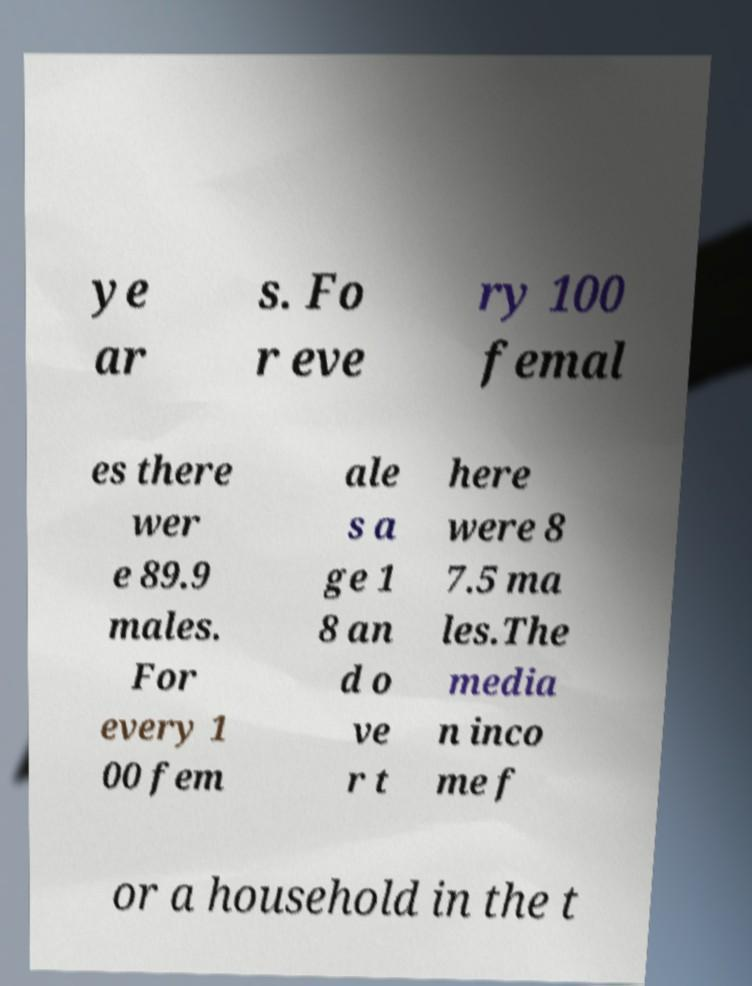Please identify and transcribe the text found in this image. ye ar s. Fo r eve ry 100 femal es there wer e 89.9 males. For every 1 00 fem ale s a ge 1 8 an d o ve r t here were 8 7.5 ma les.The media n inco me f or a household in the t 